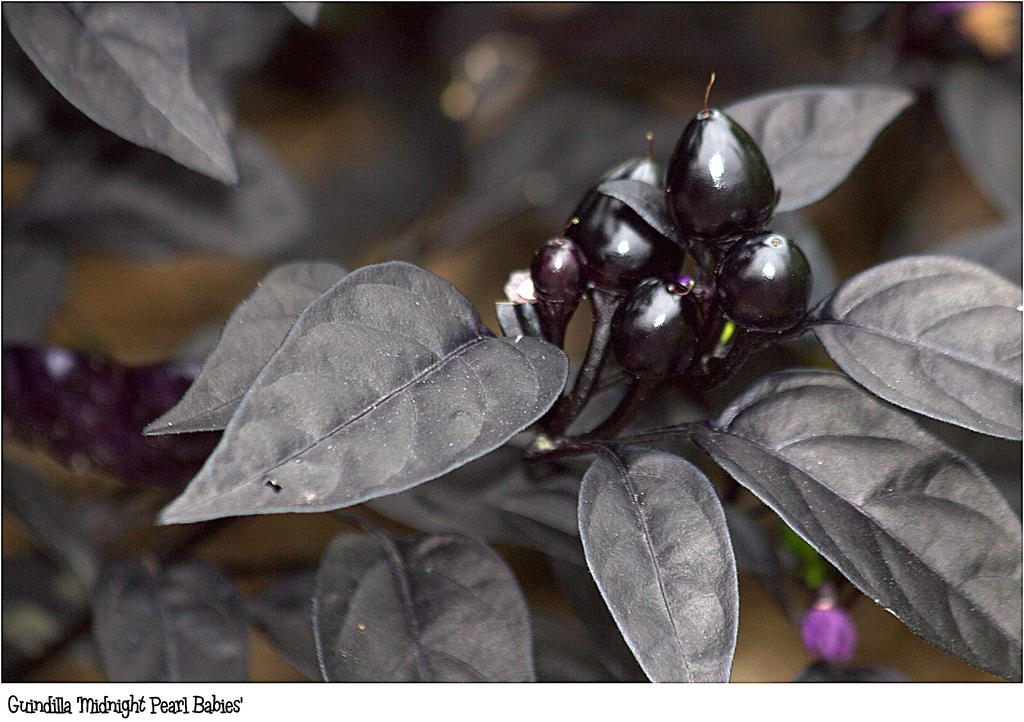What type of living organisms can be seen on the plant in the image? There are fruits on the plant in the image. Can you describe the plant's appearance? The plant's appearance is not specified in the facts, but it is bearing fruits. What might be the purpose of these fruits? The fruits on the plant may be for consumption or reproduction purposes. What type of competition is being held near the plant in the image? There is no mention of a competition in the image or the provided facts. 